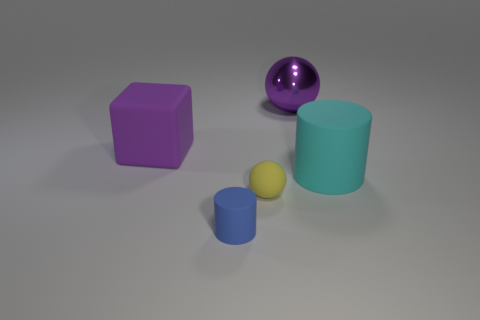The matte object that is in front of the small yellow matte thing has what shape?
Ensure brevity in your answer.  Cylinder. There is a matte thing that is the same color as the big metallic sphere; what is its size?
Your response must be concise. Large. Is there a matte object that has the same size as the matte cube?
Offer a very short reply. Yes. Do the big purple object that is in front of the big ball and the tiny ball have the same material?
Your response must be concise. Yes. Is the number of tiny blue things on the right side of the purple sphere the same as the number of big purple rubber things on the left side of the big purple cube?
Your response must be concise. Yes. What shape is the large object that is both right of the tiny rubber cylinder and in front of the large purple sphere?
Your response must be concise. Cylinder. How many small matte things are on the right side of the blue thing?
Give a very brief answer. 1. How many other things are the same shape as the big purple rubber object?
Your answer should be very brief. 0. Are there fewer big rubber cubes than gray matte cylinders?
Your answer should be very brief. No. There is a rubber object that is to the left of the rubber sphere and in front of the big cyan thing; what size is it?
Provide a short and direct response. Small. 